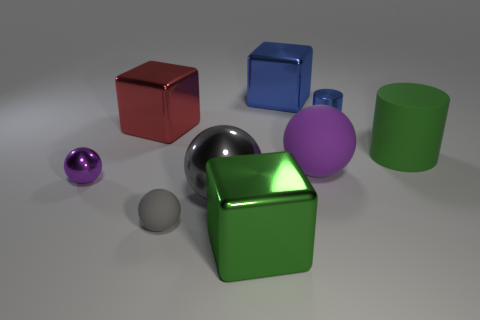There is a big purple rubber thing; are there any metal cylinders behind it? Directly behind the large purple sphere, there is not a metal cylinder, but further to the left, there is a chrome sphere that might give the impression of a metal cylinder due to its reflective surface. 